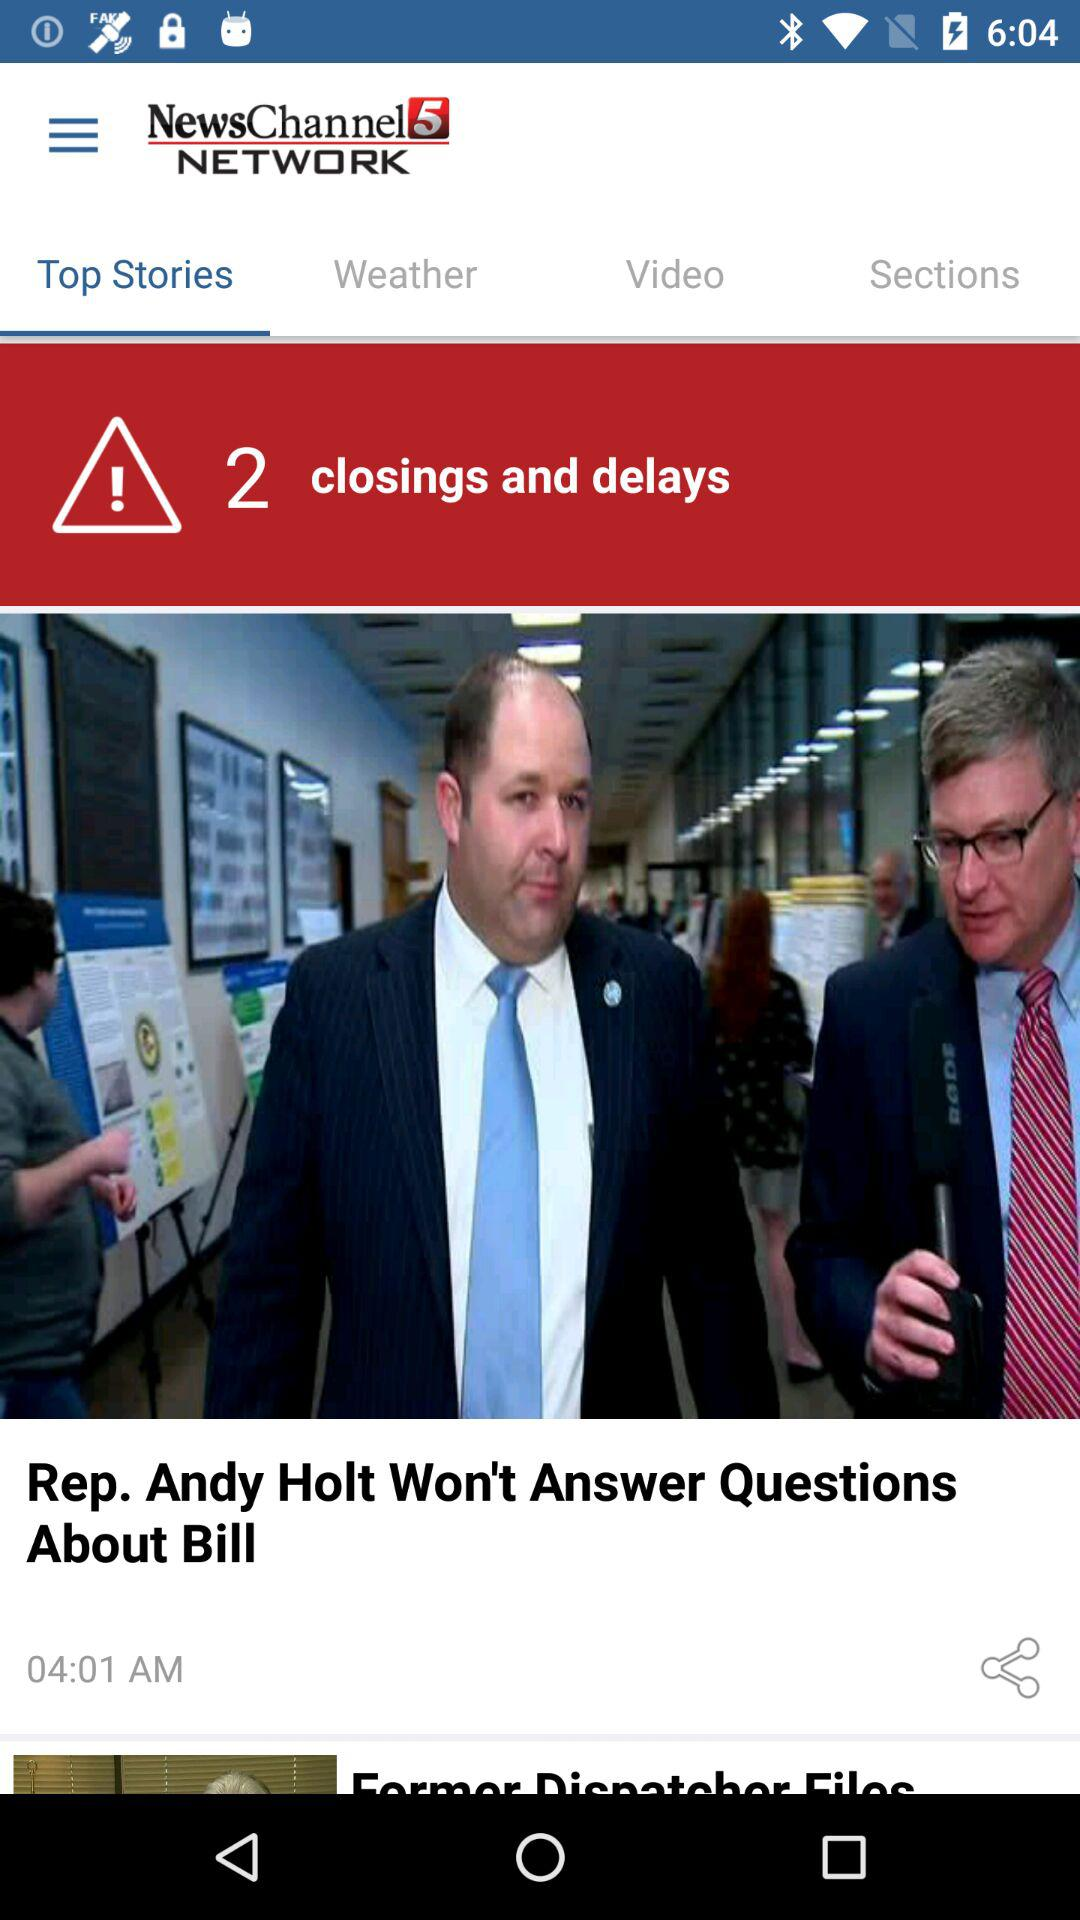Which tab is selected? The selected tab is "Top Stories". 